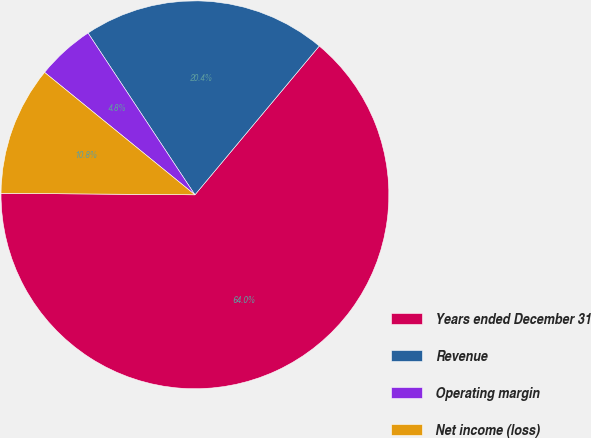<chart> <loc_0><loc_0><loc_500><loc_500><pie_chart><fcel>Years ended December 31<fcel>Revenue<fcel>Operating margin<fcel>Net income (loss)<nl><fcel>64.04%<fcel>20.37%<fcel>4.83%<fcel>10.75%<nl></chart> 